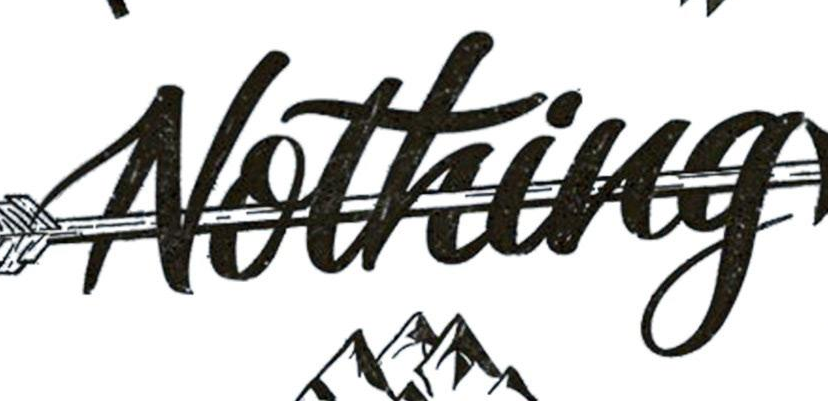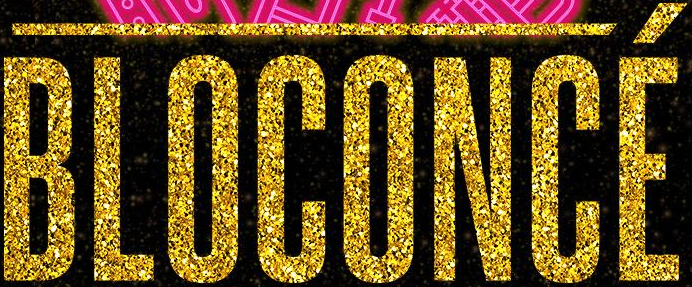Read the text from these images in sequence, separated by a semicolon. Nothing; BLOCONCÉ 